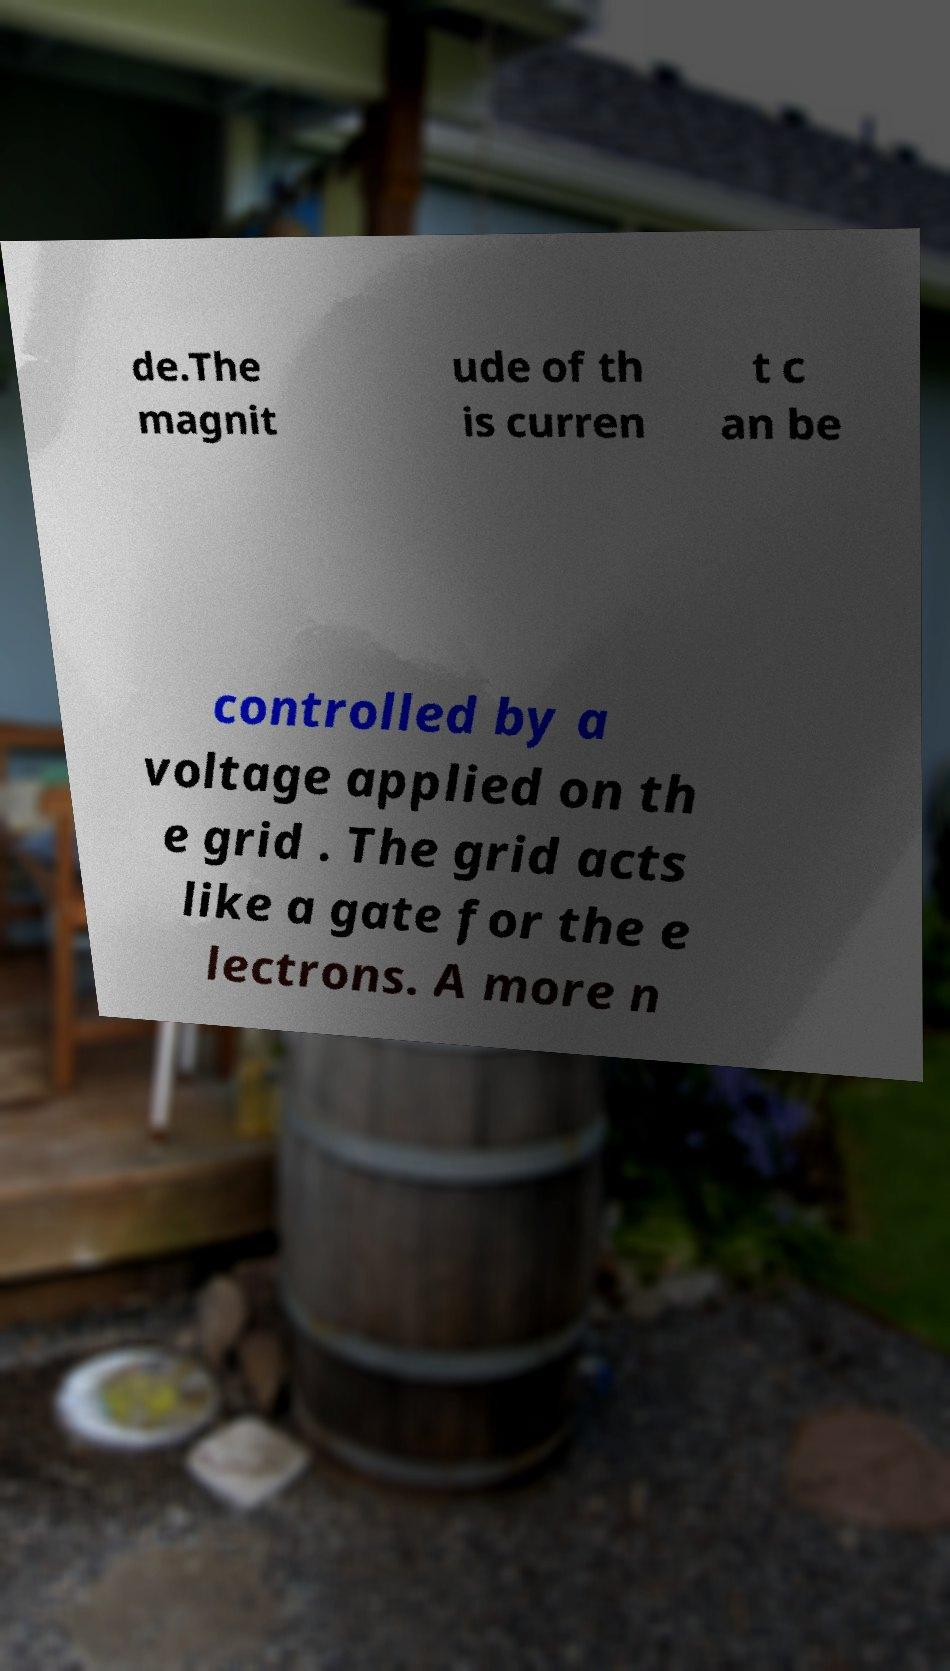Please identify and transcribe the text found in this image. de.The magnit ude of th is curren t c an be controlled by a voltage applied on th e grid . The grid acts like a gate for the e lectrons. A more n 